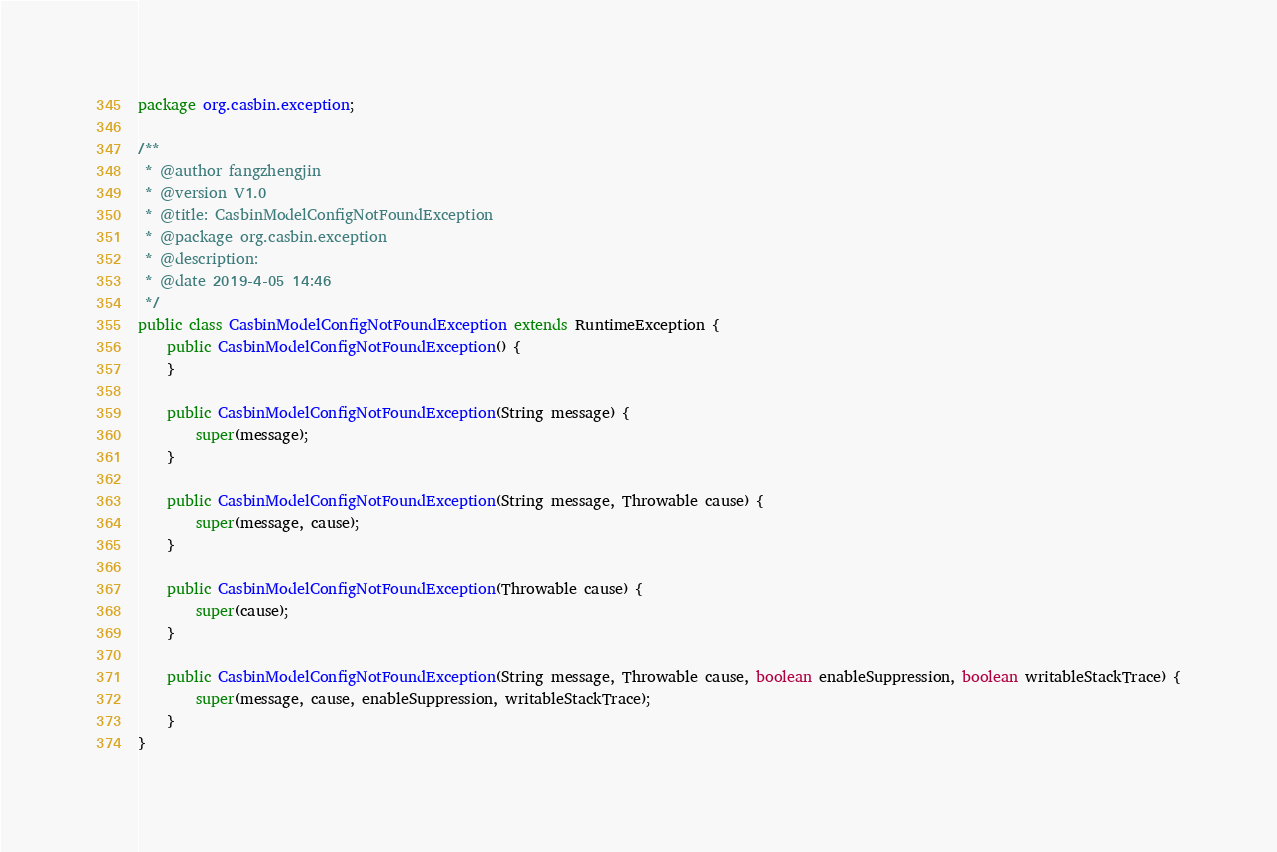<code> <loc_0><loc_0><loc_500><loc_500><_Java_>package org.casbin.exception;

/**
 * @author fangzhengjin
 * @version V1.0
 * @title: CasbinModelConfigNotFoundException
 * @package org.casbin.exception
 * @description:
 * @date 2019-4-05 14:46
 */
public class CasbinModelConfigNotFoundException extends RuntimeException {
    public CasbinModelConfigNotFoundException() {
    }

    public CasbinModelConfigNotFoundException(String message) {
        super(message);
    }

    public CasbinModelConfigNotFoundException(String message, Throwable cause) {
        super(message, cause);
    }

    public CasbinModelConfigNotFoundException(Throwable cause) {
        super(cause);
    }

    public CasbinModelConfigNotFoundException(String message, Throwable cause, boolean enableSuppression, boolean writableStackTrace) {
        super(message, cause, enableSuppression, writableStackTrace);
    }
}</code> 